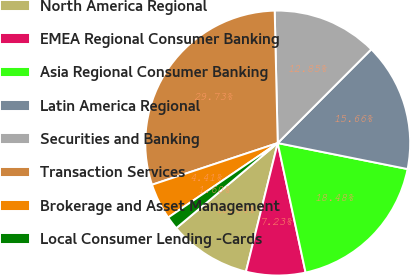Convert chart. <chart><loc_0><loc_0><loc_500><loc_500><pie_chart><fcel>North America Regional<fcel>EMEA Regional Consumer Banking<fcel>Asia Regional Consumer Banking<fcel>Latin America Regional<fcel>Securities and Banking<fcel>Transaction Services<fcel>Brokerage and Asset Management<fcel>Local Consumer Lending -Cards<nl><fcel>10.04%<fcel>7.23%<fcel>18.48%<fcel>15.66%<fcel>12.85%<fcel>29.73%<fcel>4.41%<fcel>1.6%<nl></chart> 